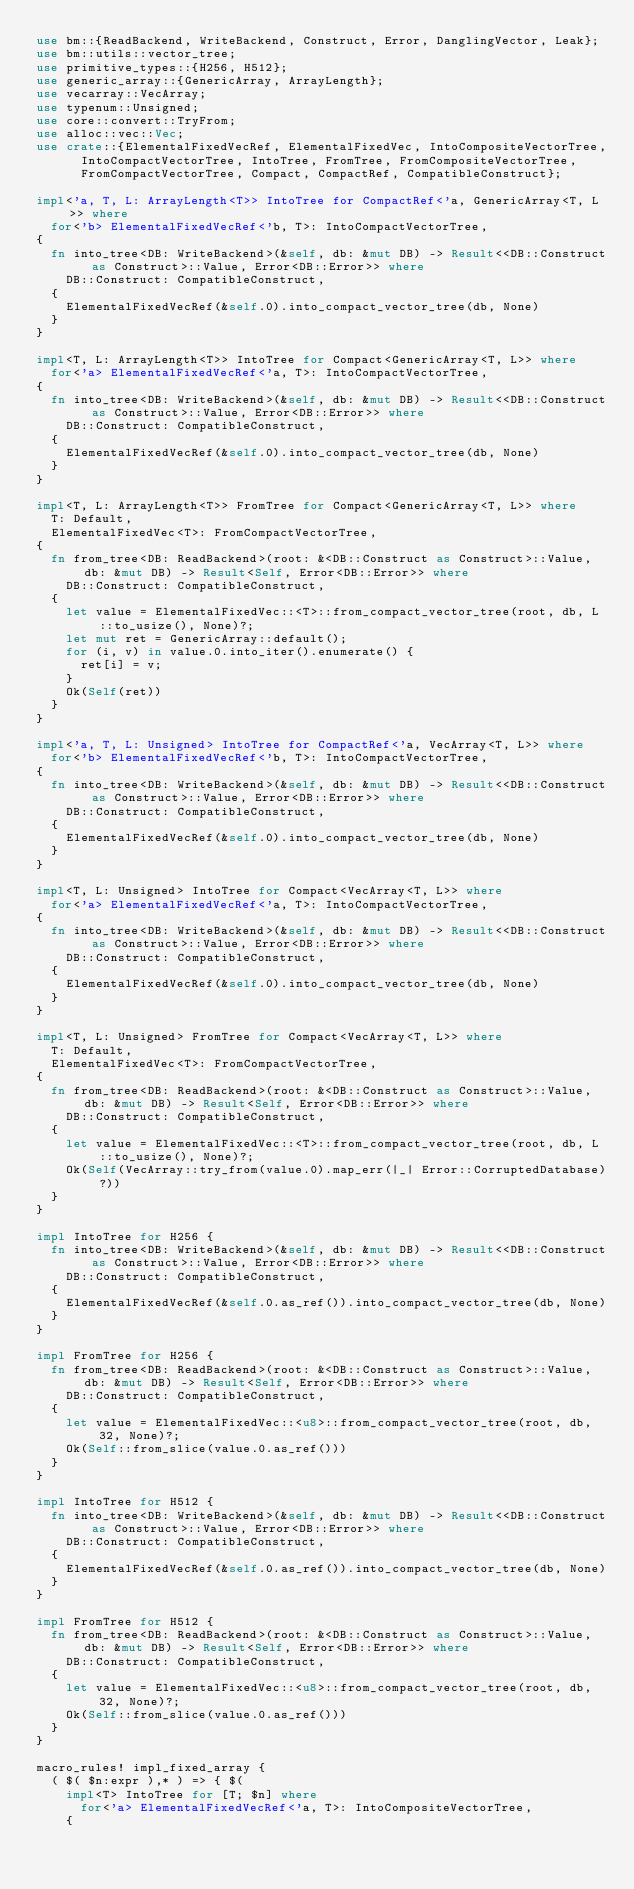Convert code to text. <code><loc_0><loc_0><loc_500><loc_500><_Rust_>use bm::{ReadBackend, WriteBackend, Construct, Error, DanglingVector, Leak};
use bm::utils::vector_tree;
use primitive_types::{H256, H512};
use generic_array::{GenericArray, ArrayLength};
use vecarray::VecArray;
use typenum::Unsigned;
use core::convert::TryFrom;
use alloc::vec::Vec;
use crate::{ElementalFixedVecRef, ElementalFixedVec, IntoCompositeVectorTree,
			IntoCompactVectorTree, IntoTree, FromTree, FromCompositeVectorTree,
			FromCompactVectorTree, Compact, CompactRef, CompatibleConstruct};

impl<'a, T, L: ArrayLength<T>> IntoTree for CompactRef<'a, GenericArray<T, L>> where
	for<'b> ElementalFixedVecRef<'b, T>: IntoCompactVectorTree,
{
	fn into_tree<DB: WriteBackend>(&self, db: &mut DB) -> Result<<DB::Construct as Construct>::Value, Error<DB::Error>> where
		DB::Construct: CompatibleConstruct,
	{
		ElementalFixedVecRef(&self.0).into_compact_vector_tree(db, None)
	}
}

impl<T, L: ArrayLength<T>> IntoTree for Compact<GenericArray<T, L>> where
	for<'a> ElementalFixedVecRef<'a, T>: IntoCompactVectorTree,
{
	fn into_tree<DB: WriteBackend>(&self, db: &mut DB) -> Result<<DB::Construct as Construct>::Value, Error<DB::Error>> where
		DB::Construct: CompatibleConstruct,
	{
		ElementalFixedVecRef(&self.0).into_compact_vector_tree(db, None)
	}
}

impl<T, L: ArrayLength<T>> FromTree for Compact<GenericArray<T, L>> where
	T: Default,
	ElementalFixedVec<T>: FromCompactVectorTree,
{
	fn from_tree<DB: ReadBackend>(root: &<DB::Construct as Construct>::Value, db: &mut DB) -> Result<Self, Error<DB::Error>> where
		DB::Construct: CompatibleConstruct,
	{
		let value = ElementalFixedVec::<T>::from_compact_vector_tree(root, db, L::to_usize(), None)?;
		let mut ret = GenericArray::default();
		for (i, v) in value.0.into_iter().enumerate() {
			ret[i] = v;
		}
		Ok(Self(ret))
	}
}

impl<'a, T, L: Unsigned> IntoTree for CompactRef<'a, VecArray<T, L>> where
	for<'b> ElementalFixedVecRef<'b, T>: IntoCompactVectorTree,
{
	fn into_tree<DB: WriteBackend>(&self, db: &mut DB) -> Result<<DB::Construct as Construct>::Value, Error<DB::Error>> where
		DB::Construct: CompatibleConstruct,
	{
		ElementalFixedVecRef(&self.0).into_compact_vector_tree(db, None)
	}
}

impl<T, L: Unsigned> IntoTree for Compact<VecArray<T, L>> where
	for<'a> ElementalFixedVecRef<'a, T>: IntoCompactVectorTree,
{
	fn into_tree<DB: WriteBackend>(&self, db: &mut DB) -> Result<<DB::Construct as Construct>::Value, Error<DB::Error>> where
		DB::Construct: CompatibleConstruct,
	{
		ElementalFixedVecRef(&self.0).into_compact_vector_tree(db, None)
	}
}

impl<T, L: Unsigned> FromTree for Compact<VecArray<T, L>> where
	T: Default,
	ElementalFixedVec<T>: FromCompactVectorTree,
{
	fn from_tree<DB: ReadBackend>(root: &<DB::Construct as Construct>::Value, db: &mut DB) -> Result<Self, Error<DB::Error>> where
		DB::Construct: CompatibleConstruct,
	{
		let value = ElementalFixedVec::<T>::from_compact_vector_tree(root, db, L::to_usize(), None)?;
		Ok(Self(VecArray::try_from(value.0).map_err(|_| Error::CorruptedDatabase)?))
	}
}

impl IntoTree for H256 {
	fn into_tree<DB: WriteBackend>(&self, db: &mut DB) -> Result<<DB::Construct as Construct>::Value, Error<DB::Error>> where
		DB::Construct: CompatibleConstruct,
	{
		ElementalFixedVecRef(&self.0.as_ref()).into_compact_vector_tree(db, None)
	}
}

impl FromTree for H256 {
	fn from_tree<DB: ReadBackend>(root: &<DB::Construct as Construct>::Value, db: &mut DB) -> Result<Self, Error<DB::Error>> where
		DB::Construct: CompatibleConstruct,
	{
		let value = ElementalFixedVec::<u8>::from_compact_vector_tree(root, db, 32, None)?;
		Ok(Self::from_slice(value.0.as_ref()))
	}
}

impl IntoTree for H512 {
	fn into_tree<DB: WriteBackend>(&self, db: &mut DB) -> Result<<DB::Construct as Construct>::Value, Error<DB::Error>> where
		DB::Construct: CompatibleConstruct,
	{
		ElementalFixedVecRef(&self.0.as_ref()).into_compact_vector_tree(db, None)
	}
}

impl FromTree for H512 {
	fn from_tree<DB: ReadBackend>(root: &<DB::Construct as Construct>::Value, db: &mut DB) -> Result<Self, Error<DB::Error>> where
		DB::Construct: CompatibleConstruct,
	{
		let value = ElementalFixedVec::<u8>::from_compact_vector_tree(root, db, 32, None)?;
		Ok(Self::from_slice(value.0.as_ref()))
	}
}

macro_rules! impl_fixed_array {
	( $( $n:expr ),* ) => { $(
		impl<T> IntoTree for [T; $n] where
			for<'a> ElementalFixedVecRef<'a, T>: IntoCompositeVectorTree,
		{</code> 